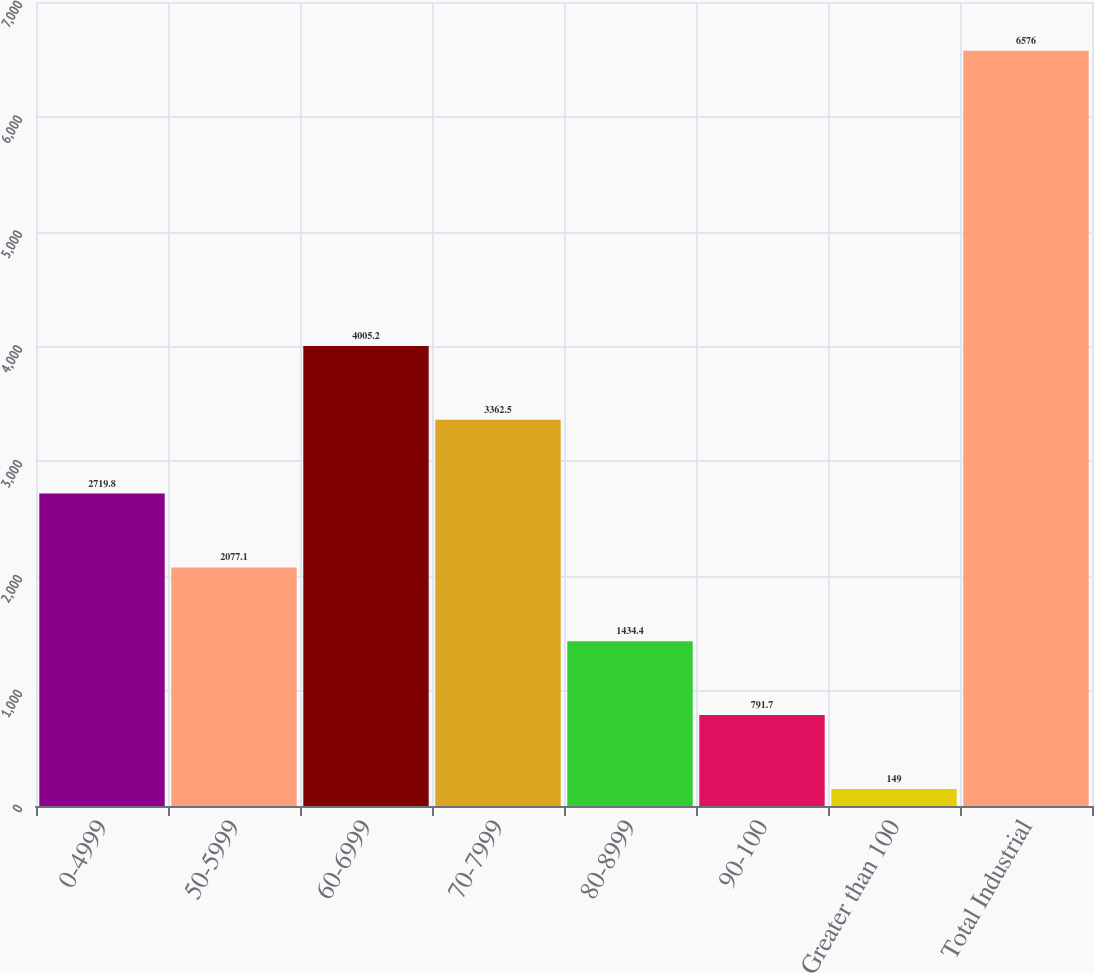<chart> <loc_0><loc_0><loc_500><loc_500><bar_chart><fcel>0-4999<fcel>50-5999<fcel>60-6999<fcel>70-7999<fcel>80-8999<fcel>90-100<fcel>Greater than 100<fcel>Total Industrial<nl><fcel>2719.8<fcel>2077.1<fcel>4005.2<fcel>3362.5<fcel>1434.4<fcel>791.7<fcel>149<fcel>6576<nl></chart> 